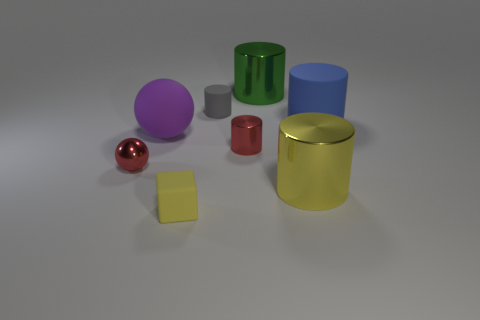Subtract all blue cylinders. How many cylinders are left? 4 Subtract 1 cubes. How many cubes are left? 0 Add 1 red metallic balls. How many objects exist? 9 Subtract all green cylinders. How many cylinders are left? 4 Add 3 blue objects. How many blue objects exist? 4 Subtract 0 blue balls. How many objects are left? 8 Subtract all cylinders. How many objects are left? 3 Subtract all purple balls. Subtract all brown blocks. How many balls are left? 1 Subtract all big rubber cylinders. Subtract all large blue rubber cylinders. How many objects are left? 6 Add 7 yellow shiny things. How many yellow shiny things are left? 8 